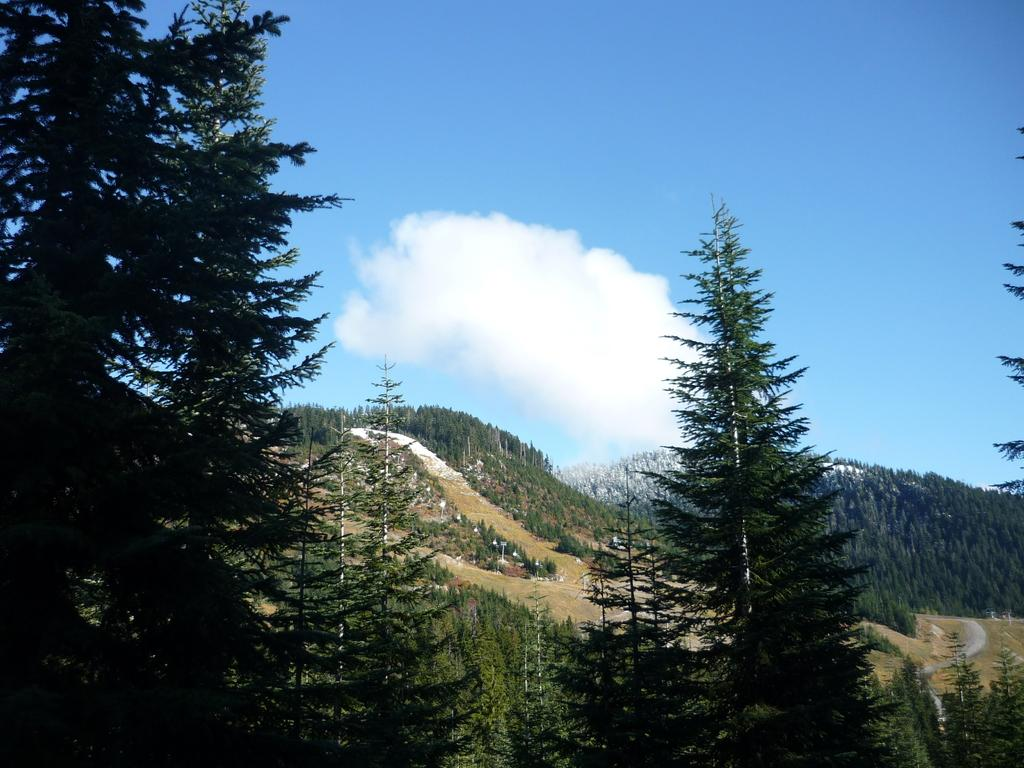What type of vegetation can be seen in the image? There are trees in the image. What is the color of the trees? The trees are green in color. What else can be seen in the image besides the trees? There is a road, the ground, mountains, and the sky visible in the image. Are there any trees on the mountains? Yes, trees are present on the mountains. What is visible in the background of the image? The sky is visible in the background of the image. What type of secretary can be seen working on a print in the image? There is no secretary or print present in the image; it features trees, a road, mountains, and the sky. 